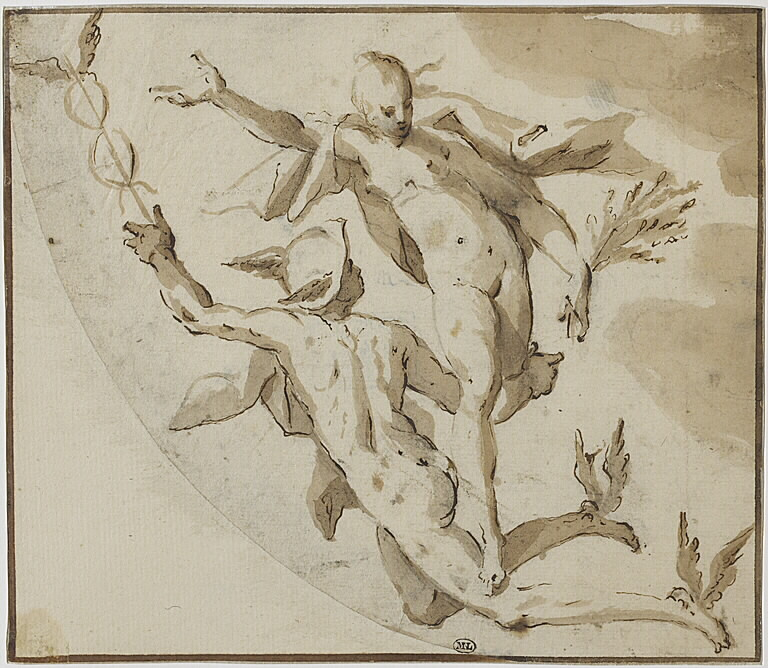If this were a scene from a play or a story, what might be happening in the plot right now? In a play or story, this scene might depict a climactic moment where the hero, represented by the male figure, is rescuing or supporting the heroine, represented by the female figure. They could be ascending together towards a triumph or an escape from danger. The dramatic pose and energetic movement suggest a turning point in the narrative, filled with tension and emotional intensity. This moment might signify victory, liberation, or the culmination of a significant struggle. 